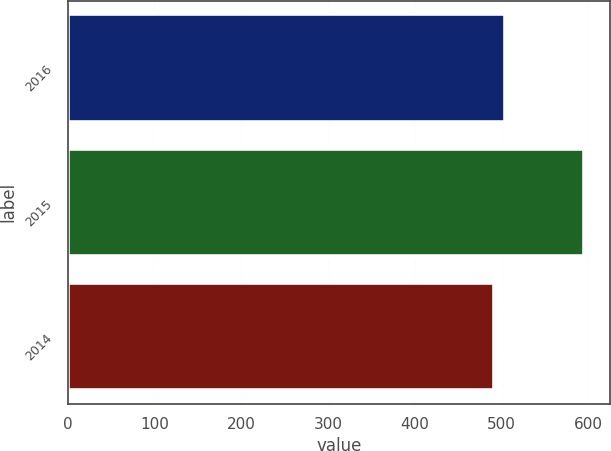<chart> <loc_0><loc_0><loc_500><loc_500><bar_chart><fcel>2016<fcel>2015<fcel>2014<nl><fcel>504<fcel>595<fcel>491<nl></chart> 